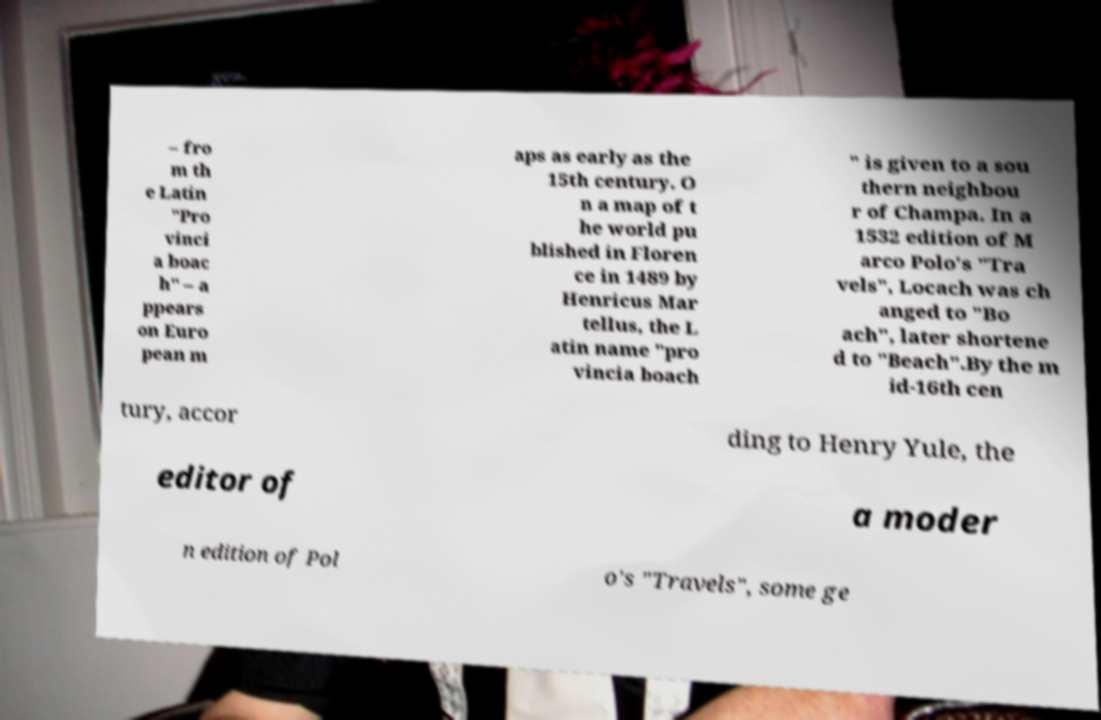There's text embedded in this image that I need extracted. Can you transcribe it verbatim? – fro m th e Latin "Pro vinci a boac h" – a ppears on Euro pean m aps as early as the 15th century. O n a map of t he world pu blished in Floren ce in 1489 by Henricus Mar tellus, the L atin name "pro vincia boach " is given to a sou thern neighbou r of Champa. In a 1532 edition of M arco Polo's "Tra vels", Locach was ch anged to "Bo ach", later shortene d to "Beach".By the m id-16th cen tury, accor ding to Henry Yule, the editor of a moder n edition of Pol o's "Travels", some ge 